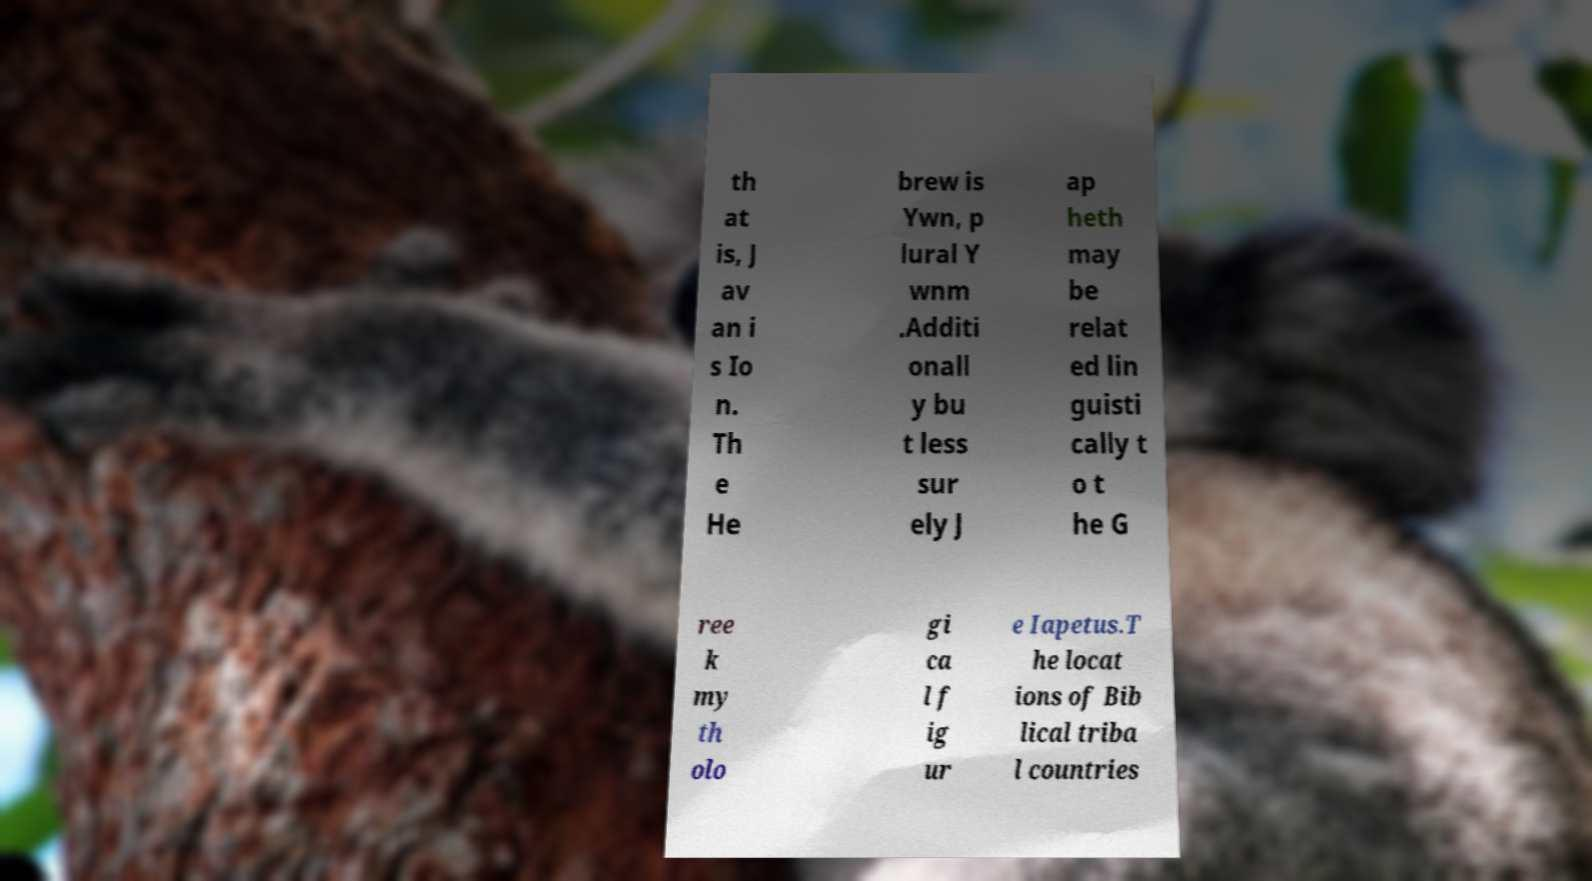Can you read and provide the text displayed in the image?This photo seems to have some interesting text. Can you extract and type it out for me? th at is, J av an i s Io n. Th e He brew is Ywn, p lural Y wnm .Additi onall y bu t less sur ely J ap heth may be relat ed lin guisti cally t o t he G ree k my th olo gi ca l f ig ur e Iapetus.T he locat ions of Bib lical triba l countries 